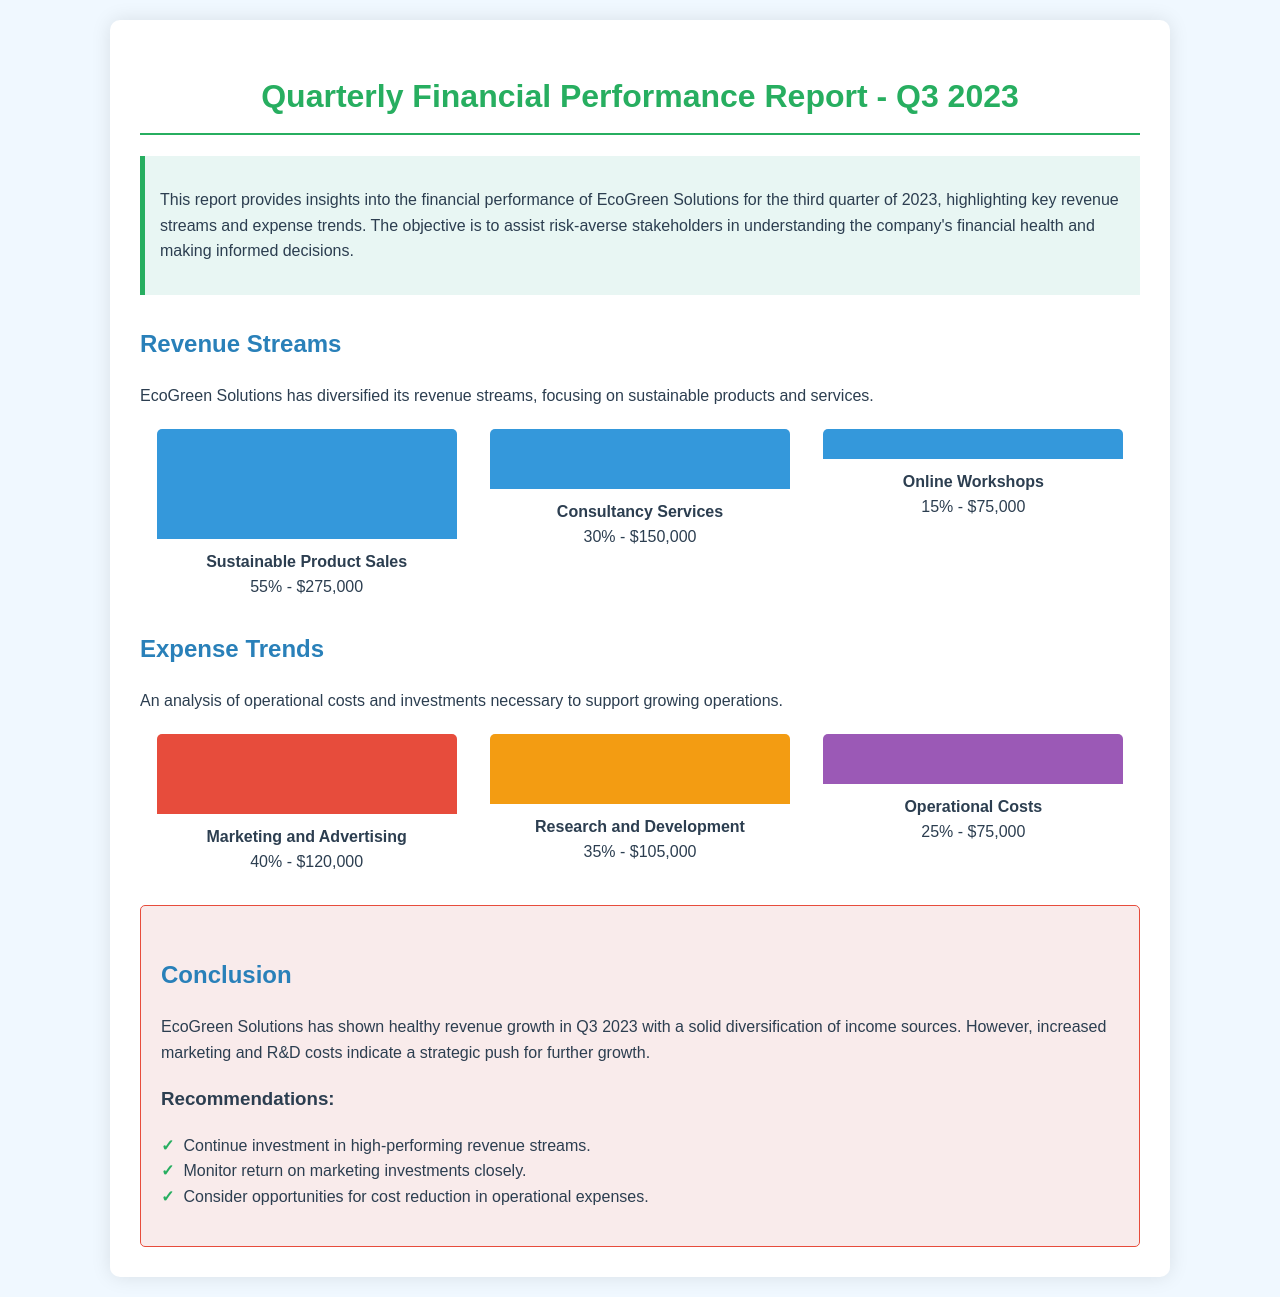What is the total revenue for Q3 2023? The total revenue is the sum of all revenue sources: $275,000 + $150,000 + $75,000 = $500,000.
Answer: $500,000 What percentage of total revenue comes from Sustainable Product Sales? Sustainable Product Sales accounts for 55% of the total revenue as indicated in the document.
Answer: 55% What is the highest expense category? The highest expense category is Marketing and Advertising with a cost of $120,000.
Answer: Marketing and Advertising What are the total expenses for Q3 2023? The total expenses are calculated by adding all expense categories: $120,000 + $105,000 + $75,000 = $300,000.
Answer: $300,000 What is the percentage of revenue derived from Online Workshops? Online Workshops contribute 15% to the total revenue as mentioned in the document.
Answer: 15% What does the conclusion suggest about EcoGreen Solutions' revenue growth? The conclusion indicates that EcoGreen Solutions has shown healthy revenue growth in Q3 2023.
Answer: Healthy revenue growth What is the total percentage of expenses attributed to Research and Development? Research and Development accounts for 35% of the total expenses according to the document.
Answer: 35% Which revenue stream has the least contribution? The revenue stream with the least contribution is Online Workshops, generating $75,000.
Answer: Online Workshops What is the strategic recommendation regarding marketing investments? The recommendation suggests to monitor return on marketing investments closely.
Answer: Monitor return on marketing investments closely 